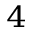Convert formula to latex. <formula><loc_0><loc_0><loc_500><loc_500>_ { 4 }</formula> 